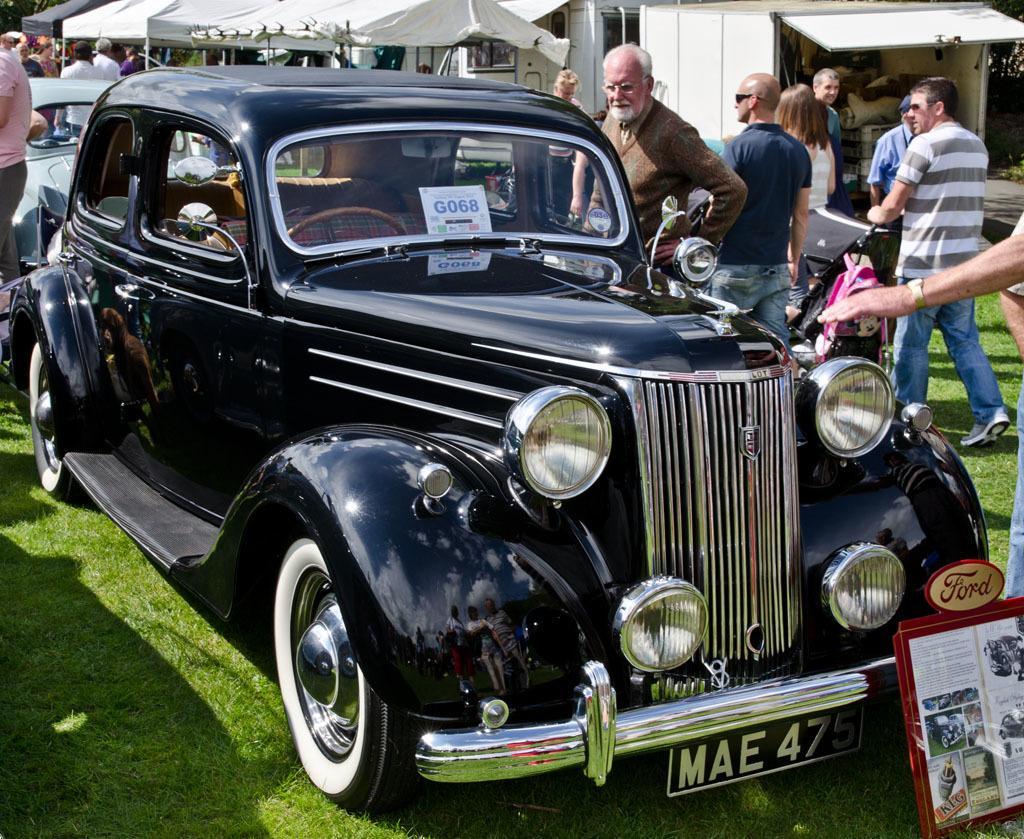Could you give a brief overview of what you see in this image? These are cars, here people are standing, these are tents, this is grass. 